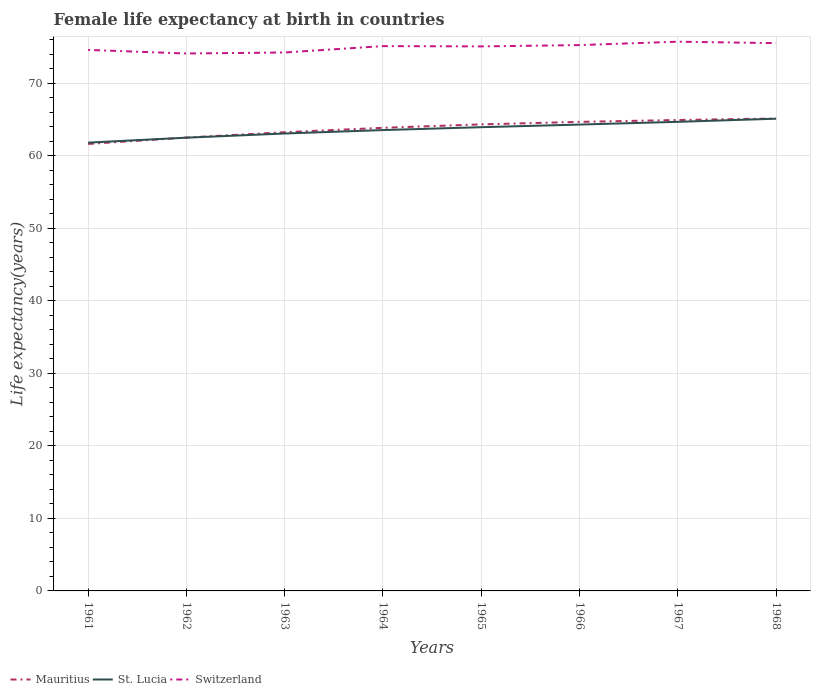Does the line corresponding to Switzerland intersect with the line corresponding to Mauritius?
Offer a terse response. No. Is the number of lines equal to the number of legend labels?
Your answer should be compact. Yes. Across all years, what is the maximum female life expectancy at birth in St. Lucia?
Your response must be concise. 61.8. In which year was the female life expectancy at birth in Switzerland maximum?
Provide a short and direct response. 1962. What is the total female life expectancy at birth in Mauritius in the graph?
Your answer should be very brief. -1.35. What is the difference between the highest and the second highest female life expectancy at birth in St. Lucia?
Offer a very short reply. 3.3. Is the female life expectancy at birth in Mauritius strictly greater than the female life expectancy at birth in St. Lucia over the years?
Your answer should be compact. No. Where does the legend appear in the graph?
Provide a short and direct response. Bottom left. What is the title of the graph?
Make the answer very short. Female life expectancy at birth in countries. Does "Congo (Republic)" appear as one of the legend labels in the graph?
Offer a very short reply. No. What is the label or title of the Y-axis?
Offer a very short reply. Life expectancy(years). What is the Life expectancy(years) in Mauritius in 1961?
Ensure brevity in your answer.  61.62. What is the Life expectancy(years) in St. Lucia in 1961?
Offer a terse response. 61.8. What is the Life expectancy(years) in Switzerland in 1961?
Ensure brevity in your answer.  74.59. What is the Life expectancy(years) of Mauritius in 1962?
Offer a terse response. 62.5. What is the Life expectancy(years) of St. Lucia in 1962?
Offer a very short reply. 62.49. What is the Life expectancy(years) in Switzerland in 1962?
Provide a succinct answer. 74.09. What is the Life expectancy(years) in Mauritius in 1963?
Keep it short and to the point. 63.24. What is the Life expectancy(years) of St. Lucia in 1963?
Make the answer very short. 63.06. What is the Life expectancy(years) in Switzerland in 1963?
Provide a short and direct response. 74.23. What is the Life expectancy(years) in Mauritius in 1964?
Keep it short and to the point. 63.85. What is the Life expectancy(years) in St. Lucia in 1964?
Your answer should be very brief. 63.53. What is the Life expectancy(years) in Switzerland in 1964?
Offer a terse response. 75.11. What is the Life expectancy(years) of Mauritius in 1965?
Give a very brief answer. 64.32. What is the Life expectancy(years) of St. Lucia in 1965?
Your answer should be very brief. 63.93. What is the Life expectancy(years) in Switzerland in 1965?
Your response must be concise. 75.07. What is the Life expectancy(years) in Mauritius in 1966?
Your answer should be very brief. 64.67. What is the Life expectancy(years) of St. Lucia in 1966?
Ensure brevity in your answer.  64.29. What is the Life expectancy(years) of Switzerland in 1966?
Offer a very short reply. 75.25. What is the Life expectancy(years) in Mauritius in 1967?
Ensure brevity in your answer.  64.92. What is the Life expectancy(years) of St. Lucia in 1967?
Provide a short and direct response. 64.67. What is the Life expectancy(years) in Switzerland in 1967?
Make the answer very short. 75.72. What is the Life expectancy(years) in Mauritius in 1968?
Make the answer very short. 65.13. What is the Life expectancy(years) of St. Lucia in 1968?
Your answer should be compact. 65.1. What is the Life expectancy(years) in Switzerland in 1968?
Provide a short and direct response. 75.52. Across all years, what is the maximum Life expectancy(years) of Mauritius?
Ensure brevity in your answer.  65.13. Across all years, what is the maximum Life expectancy(years) in St. Lucia?
Your answer should be compact. 65.1. Across all years, what is the maximum Life expectancy(years) in Switzerland?
Your response must be concise. 75.72. Across all years, what is the minimum Life expectancy(years) in Mauritius?
Your answer should be compact. 61.62. Across all years, what is the minimum Life expectancy(years) of St. Lucia?
Your answer should be compact. 61.8. Across all years, what is the minimum Life expectancy(years) of Switzerland?
Your response must be concise. 74.09. What is the total Life expectancy(years) in Mauritius in the graph?
Offer a very short reply. 510.25. What is the total Life expectancy(years) of St. Lucia in the graph?
Your answer should be compact. 508.89. What is the total Life expectancy(years) in Switzerland in the graph?
Offer a terse response. 599.58. What is the difference between the Life expectancy(years) of Mauritius in 1961 and that in 1962?
Provide a short and direct response. -0.88. What is the difference between the Life expectancy(years) in St. Lucia in 1961 and that in 1962?
Keep it short and to the point. -0.68. What is the difference between the Life expectancy(years) of Switzerland in 1961 and that in 1962?
Your response must be concise. 0.5. What is the difference between the Life expectancy(years) of Mauritius in 1961 and that in 1963?
Your response must be concise. -1.62. What is the difference between the Life expectancy(years) in St. Lucia in 1961 and that in 1963?
Offer a very short reply. -1.26. What is the difference between the Life expectancy(years) of Switzerland in 1961 and that in 1963?
Provide a short and direct response. 0.36. What is the difference between the Life expectancy(years) in Mauritius in 1961 and that in 1964?
Ensure brevity in your answer.  -2.23. What is the difference between the Life expectancy(years) of St. Lucia in 1961 and that in 1964?
Offer a very short reply. -1.73. What is the difference between the Life expectancy(years) of Switzerland in 1961 and that in 1964?
Ensure brevity in your answer.  -0.52. What is the difference between the Life expectancy(years) in Mauritius in 1961 and that in 1965?
Offer a very short reply. -2.7. What is the difference between the Life expectancy(years) in St. Lucia in 1961 and that in 1965?
Your answer should be very brief. -2.13. What is the difference between the Life expectancy(years) of Switzerland in 1961 and that in 1965?
Keep it short and to the point. -0.48. What is the difference between the Life expectancy(years) of Mauritius in 1961 and that in 1966?
Your answer should be compact. -3.04. What is the difference between the Life expectancy(years) in St. Lucia in 1961 and that in 1966?
Offer a very short reply. -2.49. What is the difference between the Life expectancy(years) in Switzerland in 1961 and that in 1966?
Keep it short and to the point. -0.66. What is the difference between the Life expectancy(years) in St. Lucia in 1961 and that in 1967?
Make the answer very short. -2.87. What is the difference between the Life expectancy(years) in Switzerland in 1961 and that in 1967?
Provide a succinct answer. -1.13. What is the difference between the Life expectancy(years) of Mauritius in 1961 and that in 1968?
Provide a succinct answer. -3.51. What is the difference between the Life expectancy(years) in St. Lucia in 1961 and that in 1968?
Keep it short and to the point. -3.3. What is the difference between the Life expectancy(years) of Switzerland in 1961 and that in 1968?
Offer a terse response. -0.93. What is the difference between the Life expectancy(years) of Mauritius in 1962 and that in 1963?
Your response must be concise. -0.74. What is the difference between the Life expectancy(years) of St. Lucia in 1962 and that in 1963?
Ensure brevity in your answer.  -0.57. What is the difference between the Life expectancy(years) of Switzerland in 1962 and that in 1963?
Offer a very short reply. -0.14. What is the difference between the Life expectancy(years) of Mauritius in 1962 and that in 1964?
Give a very brief answer. -1.35. What is the difference between the Life expectancy(years) in St. Lucia in 1962 and that in 1964?
Your answer should be compact. -1.05. What is the difference between the Life expectancy(years) of Switzerland in 1962 and that in 1964?
Provide a short and direct response. -1.02. What is the difference between the Life expectancy(years) in Mauritius in 1962 and that in 1965?
Give a very brief answer. -1.82. What is the difference between the Life expectancy(years) of St. Lucia in 1962 and that in 1965?
Make the answer very short. -1.45. What is the difference between the Life expectancy(years) in Switzerland in 1962 and that in 1965?
Make the answer very short. -0.98. What is the difference between the Life expectancy(years) of Mauritius in 1962 and that in 1966?
Your answer should be compact. -2.17. What is the difference between the Life expectancy(years) in St. Lucia in 1962 and that in 1966?
Give a very brief answer. -1.81. What is the difference between the Life expectancy(years) in Switzerland in 1962 and that in 1966?
Your answer should be very brief. -1.16. What is the difference between the Life expectancy(years) of Mauritius in 1962 and that in 1967?
Keep it short and to the point. -2.42. What is the difference between the Life expectancy(years) of St. Lucia in 1962 and that in 1967?
Make the answer very short. -2.19. What is the difference between the Life expectancy(years) of Switzerland in 1962 and that in 1967?
Your response must be concise. -1.63. What is the difference between the Life expectancy(years) in Mauritius in 1962 and that in 1968?
Provide a short and direct response. -2.63. What is the difference between the Life expectancy(years) in St. Lucia in 1962 and that in 1968?
Your response must be concise. -2.62. What is the difference between the Life expectancy(years) of Switzerland in 1962 and that in 1968?
Your answer should be very brief. -1.43. What is the difference between the Life expectancy(years) in Mauritius in 1963 and that in 1964?
Your response must be concise. -0.61. What is the difference between the Life expectancy(years) in St. Lucia in 1963 and that in 1964?
Give a very brief answer. -0.47. What is the difference between the Life expectancy(years) of Switzerland in 1963 and that in 1964?
Your answer should be very brief. -0.88. What is the difference between the Life expectancy(years) in Mauritius in 1963 and that in 1965?
Offer a very short reply. -1.08. What is the difference between the Life expectancy(years) in St. Lucia in 1963 and that in 1965?
Provide a succinct answer. -0.87. What is the difference between the Life expectancy(years) in Switzerland in 1963 and that in 1965?
Provide a short and direct response. -0.84. What is the difference between the Life expectancy(years) in Mauritius in 1963 and that in 1966?
Your answer should be very brief. -1.43. What is the difference between the Life expectancy(years) in St. Lucia in 1963 and that in 1966?
Your answer should be compact. -1.23. What is the difference between the Life expectancy(years) in Switzerland in 1963 and that in 1966?
Ensure brevity in your answer.  -1.02. What is the difference between the Life expectancy(years) of Mauritius in 1963 and that in 1967?
Offer a terse response. -1.68. What is the difference between the Life expectancy(years) in St. Lucia in 1963 and that in 1967?
Make the answer very short. -1.61. What is the difference between the Life expectancy(years) of Switzerland in 1963 and that in 1967?
Offer a terse response. -1.49. What is the difference between the Life expectancy(years) in Mauritius in 1963 and that in 1968?
Your answer should be compact. -1.89. What is the difference between the Life expectancy(years) of St. Lucia in 1963 and that in 1968?
Your response must be concise. -2.04. What is the difference between the Life expectancy(years) of Switzerland in 1963 and that in 1968?
Your response must be concise. -1.29. What is the difference between the Life expectancy(years) in Mauritius in 1964 and that in 1965?
Your answer should be very brief. -0.47. What is the difference between the Life expectancy(years) in St. Lucia in 1964 and that in 1965?
Give a very brief answer. -0.4. What is the difference between the Life expectancy(years) in Switzerland in 1964 and that in 1965?
Your response must be concise. 0.04. What is the difference between the Life expectancy(years) of Mauritius in 1964 and that in 1966?
Your answer should be compact. -0.82. What is the difference between the Life expectancy(years) in St. Lucia in 1964 and that in 1966?
Your answer should be compact. -0.76. What is the difference between the Life expectancy(years) in Switzerland in 1964 and that in 1966?
Offer a very short reply. -0.14. What is the difference between the Life expectancy(years) in Mauritius in 1964 and that in 1967?
Your answer should be compact. -1.07. What is the difference between the Life expectancy(years) of St. Lucia in 1964 and that in 1967?
Your answer should be very brief. -1.14. What is the difference between the Life expectancy(years) in Switzerland in 1964 and that in 1967?
Make the answer very short. -0.61. What is the difference between the Life expectancy(years) of Mauritius in 1964 and that in 1968?
Your response must be concise. -1.28. What is the difference between the Life expectancy(years) of St. Lucia in 1964 and that in 1968?
Make the answer very short. -1.57. What is the difference between the Life expectancy(years) in Switzerland in 1964 and that in 1968?
Give a very brief answer. -0.41. What is the difference between the Life expectancy(years) in Mauritius in 1965 and that in 1966?
Keep it short and to the point. -0.35. What is the difference between the Life expectancy(years) of St. Lucia in 1965 and that in 1966?
Provide a succinct answer. -0.36. What is the difference between the Life expectancy(years) in Switzerland in 1965 and that in 1966?
Provide a short and direct response. -0.18. What is the difference between the Life expectancy(years) of Mauritius in 1965 and that in 1967?
Your answer should be compact. -0.6. What is the difference between the Life expectancy(years) of St. Lucia in 1965 and that in 1967?
Offer a very short reply. -0.74. What is the difference between the Life expectancy(years) of Switzerland in 1965 and that in 1967?
Provide a succinct answer. -0.65. What is the difference between the Life expectancy(years) of Mauritius in 1965 and that in 1968?
Offer a very short reply. -0.81. What is the difference between the Life expectancy(years) in St. Lucia in 1965 and that in 1968?
Keep it short and to the point. -1.17. What is the difference between the Life expectancy(years) in Switzerland in 1965 and that in 1968?
Offer a very short reply. -0.45. What is the difference between the Life expectancy(years) in Mauritius in 1966 and that in 1967?
Your response must be concise. -0.26. What is the difference between the Life expectancy(years) of St. Lucia in 1966 and that in 1967?
Your answer should be very brief. -0.38. What is the difference between the Life expectancy(years) in Switzerland in 1966 and that in 1967?
Provide a short and direct response. -0.47. What is the difference between the Life expectancy(years) of Mauritius in 1966 and that in 1968?
Give a very brief answer. -0.46. What is the difference between the Life expectancy(years) of St. Lucia in 1966 and that in 1968?
Your response must be concise. -0.81. What is the difference between the Life expectancy(years) in Switzerland in 1966 and that in 1968?
Give a very brief answer. -0.27. What is the difference between the Life expectancy(years) in Mauritius in 1967 and that in 1968?
Make the answer very short. -0.21. What is the difference between the Life expectancy(years) in St. Lucia in 1967 and that in 1968?
Offer a very short reply. -0.43. What is the difference between the Life expectancy(years) in Switzerland in 1967 and that in 1968?
Make the answer very short. 0.2. What is the difference between the Life expectancy(years) of Mauritius in 1961 and the Life expectancy(years) of St. Lucia in 1962?
Your answer should be very brief. -0.86. What is the difference between the Life expectancy(years) of Mauritius in 1961 and the Life expectancy(years) of Switzerland in 1962?
Provide a short and direct response. -12.47. What is the difference between the Life expectancy(years) of St. Lucia in 1961 and the Life expectancy(years) of Switzerland in 1962?
Offer a very short reply. -12.29. What is the difference between the Life expectancy(years) of Mauritius in 1961 and the Life expectancy(years) of St. Lucia in 1963?
Make the answer very short. -1.44. What is the difference between the Life expectancy(years) of Mauritius in 1961 and the Life expectancy(years) of Switzerland in 1963?
Give a very brief answer. -12.61. What is the difference between the Life expectancy(years) in St. Lucia in 1961 and the Life expectancy(years) in Switzerland in 1963?
Ensure brevity in your answer.  -12.43. What is the difference between the Life expectancy(years) of Mauritius in 1961 and the Life expectancy(years) of St. Lucia in 1964?
Provide a short and direct response. -1.91. What is the difference between the Life expectancy(years) of Mauritius in 1961 and the Life expectancy(years) of Switzerland in 1964?
Offer a terse response. -13.49. What is the difference between the Life expectancy(years) in St. Lucia in 1961 and the Life expectancy(years) in Switzerland in 1964?
Provide a succinct answer. -13.31. What is the difference between the Life expectancy(years) of Mauritius in 1961 and the Life expectancy(years) of St. Lucia in 1965?
Your answer should be compact. -2.31. What is the difference between the Life expectancy(years) in Mauritius in 1961 and the Life expectancy(years) in Switzerland in 1965?
Ensure brevity in your answer.  -13.45. What is the difference between the Life expectancy(years) in St. Lucia in 1961 and the Life expectancy(years) in Switzerland in 1965?
Ensure brevity in your answer.  -13.27. What is the difference between the Life expectancy(years) of Mauritius in 1961 and the Life expectancy(years) of St. Lucia in 1966?
Provide a succinct answer. -2.67. What is the difference between the Life expectancy(years) of Mauritius in 1961 and the Life expectancy(years) of Switzerland in 1966?
Your response must be concise. -13.63. What is the difference between the Life expectancy(years) of St. Lucia in 1961 and the Life expectancy(years) of Switzerland in 1966?
Provide a short and direct response. -13.45. What is the difference between the Life expectancy(years) of Mauritius in 1961 and the Life expectancy(years) of St. Lucia in 1967?
Keep it short and to the point. -3.05. What is the difference between the Life expectancy(years) of Mauritius in 1961 and the Life expectancy(years) of Switzerland in 1967?
Ensure brevity in your answer.  -14.1. What is the difference between the Life expectancy(years) of St. Lucia in 1961 and the Life expectancy(years) of Switzerland in 1967?
Provide a succinct answer. -13.92. What is the difference between the Life expectancy(years) of Mauritius in 1961 and the Life expectancy(years) of St. Lucia in 1968?
Give a very brief answer. -3.48. What is the difference between the Life expectancy(years) of Mauritius in 1961 and the Life expectancy(years) of Switzerland in 1968?
Provide a succinct answer. -13.9. What is the difference between the Life expectancy(years) in St. Lucia in 1961 and the Life expectancy(years) in Switzerland in 1968?
Ensure brevity in your answer.  -13.72. What is the difference between the Life expectancy(years) of Mauritius in 1962 and the Life expectancy(years) of St. Lucia in 1963?
Offer a very short reply. -0.56. What is the difference between the Life expectancy(years) in Mauritius in 1962 and the Life expectancy(years) in Switzerland in 1963?
Provide a short and direct response. -11.73. What is the difference between the Life expectancy(years) in St. Lucia in 1962 and the Life expectancy(years) in Switzerland in 1963?
Ensure brevity in your answer.  -11.74. What is the difference between the Life expectancy(years) in Mauritius in 1962 and the Life expectancy(years) in St. Lucia in 1964?
Your answer should be very brief. -1.03. What is the difference between the Life expectancy(years) of Mauritius in 1962 and the Life expectancy(years) of Switzerland in 1964?
Offer a very short reply. -12.61. What is the difference between the Life expectancy(years) in St. Lucia in 1962 and the Life expectancy(years) in Switzerland in 1964?
Ensure brevity in your answer.  -12.62. What is the difference between the Life expectancy(years) of Mauritius in 1962 and the Life expectancy(years) of St. Lucia in 1965?
Keep it short and to the point. -1.43. What is the difference between the Life expectancy(years) of Mauritius in 1962 and the Life expectancy(years) of Switzerland in 1965?
Ensure brevity in your answer.  -12.57. What is the difference between the Life expectancy(years) of St. Lucia in 1962 and the Life expectancy(years) of Switzerland in 1965?
Ensure brevity in your answer.  -12.58. What is the difference between the Life expectancy(years) of Mauritius in 1962 and the Life expectancy(years) of St. Lucia in 1966?
Your answer should be compact. -1.79. What is the difference between the Life expectancy(years) of Mauritius in 1962 and the Life expectancy(years) of Switzerland in 1966?
Keep it short and to the point. -12.75. What is the difference between the Life expectancy(years) of St. Lucia in 1962 and the Life expectancy(years) of Switzerland in 1966?
Make the answer very short. -12.76. What is the difference between the Life expectancy(years) of Mauritius in 1962 and the Life expectancy(years) of St. Lucia in 1967?
Provide a succinct answer. -2.17. What is the difference between the Life expectancy(years) of Mauritius in 1962 and the Life expectancy(years) of Switzerland in 1967?
Your answer should be very brief. -13.22. What is the difference between the Life expectancy(years) of St. Lucia in 1962 and the Life expectancy(years) of Switzerland in 1967?
Your answer should be compact. -13.23. What is the difference between the Life expectancy(years) of Mauritius in 1962 and the Life expectancy(years) of St. Lucia in 1968?
Provide a short and direct response. -2.6. What is the difference between the Life expectancy(years) of Mauritius in 1962 and the Life expectancy(years) of Switzerland in 1968?
Provide a short and direct response. -13.02. What is the difference between the Life expectancy(years) of St. Lucia in 1962 and the Life expectancy(years) of Switzerland in 1968?
Ensure brevity in your answer.  -13.03. What is the difference between the Life expectancy(years) of Mauritius in 1963 and the Life expectancy(years) of St. Lucia in 1964?
Give a very brief answer. -0.29. What is the difference between the Life expectancy(years) in Mauritius in 1963 and the Life expectancy(years) in Switzerland in 1964?
Provide a succinct answer. -11.87. What is the difference between the Life expectancy(years) in St. Lucia in 1963 and the Life expectancy(years) in Switzerland in 1964?
Your answer should be very brief. -12.05. What is the difference between the Life expectancy(years) in Mauritius in 1963 and the Life expectancy(years) in St. Lucia in 1965?
Offer a very short reply. -0.69. What is the difference between the Life expectancy(years) in Mauritius in 1963 and the Life expectancy(years) in Switzerland in 1965?
Provide a short and direct response. -11.83. What is the difference between the Life expectancy(years) of St. Lucia in 1963 and the Life expectancy(years) of Switzerland in 1965?
Provide a short and direct response. -12.01. What is the difference between the Life expectancy(years) in Mauritius in 1963 and the Life expectancy(years) in St. Lucia in 1966?
Ensure brevity in your answer.  -1.05. What is the difference between the Life expectancy(years) in Mauritius in 1963 and the Life expectancy(years) in Switzerland in 1966?
Provide a succinct answer. -12.01. What is the difference between the Life expectancy(years) of St. Lucia in 1963 and the Life expectancy(years) of Switzerland in 1966?
Offer a very short reply. -12.19. What is the difference between the Life expectancy(years) in Mauritius in 1963 and the Life expectancy(years) in St. Lucia in 1967?
Provide a short and direct response. -1.43. What is the difference between the Life expectancy(years) of Mauritius in 1963 and the Life expectancy(years) of Switzerland in 1967?
Offer a terse response. -12.48. What is the difference between the Life expectancy(years) of St. Lucia in 1963 and the Life expectancy(years) of Switzerland in 1967?
Ensure brevity in your answer.  -12.66. What is the difference between the Life expectancy(years) in Mauritius in 1963 and the Life expectancy(years) in St. Lucia in 1968?
Provide a succinct answer. -1.86. What is the difference between the Life expectancy(years) in Mauritius in 1963 and the Life expectancy(years) in Switzerland in 1968?
Provide a succinct answer. -12.28. What is the difference between the Life expectancy(years) of St. Lucia in 1963 and the Life expectancy(years) of Switzerland in 1968?
Provide a succinct answer. -12.46. What is the difference between the Life expectancy(years) in Mauritius in 1964 and the Life expectancy(years) in St. Lucia in 1965?
Provide a short and direct response. -0.08. What is the difference between the Life expectancy(years) in Mauritius in 1964 and the Life expectancy(years) in Switzerland in 1965?
Give a very brief answer. -11.22. What is the difference between the Life expectancy(years) of St. Lucia in 1964 and the Life expectancy(years) of Switzerland in 1965?
Give a very brief answer. -11.54. What is the difference between the Life expectancy(years) in Mauritius in 1964 and the Life expectancy(years) in St. Lucia in 1966?
Offer a terse response. -0.45. What is the difference between the Life expectancy(years) of Mauritius in 1964 and the Life expectancy(years) of Switzerland in 1966?
Keep it short and to the point. -11.4. What is the difference between the Life expectancy(years) of St. Lucia in 1964 and the Life expectancy(years) of Switzerland in 1966?
Your answer should be compact. -11.71. What is the difference between the Life expectancy(years) of Mauritius in 1964 and the Life expectancy(years) of St. Lucia in 1967?
Offer a terse response. -0.82. What is the difference between the Life expectancy(years) in Mauritius in 1964 and the Life expectancy(years) in Switzerland in 1967?
Offer a very short reply. -11.87. What is the difference between the Life expectancy(years) of St. Lucia in 1964 and the Life expectancy(years) of Switzerland in 1967?
Keep it short and to the point. -12.19. What is the difference between the Life expectancy(years) in Mauritius in 1964 and the Life expectancy(years) in St. Lucia in 1968?
Your answer should be compact. -1.25. What is the difference between the Life expectancy(years) of Mauritius in 1964 and the Life expectancy(years) of Switzerland in 1968?
Offer a very short reply. -11.67. What is the difference between the Life expectancy(years) of St. Lucia in 1964 and the Life expectancy(years) of Switzerland in 1968?
Provide a succinct answer. -11.98. What is the difference between the Life expectancy(years) of Mauritius in 1965 and the Life expectancy(years) of St. Lucia in 1966?
Give a very brief answer. 0.03. What is the difference between the Life expectancy(years) in Mauritius in 1965 and the Life expectancy(years) in Switzerland in 1966?
Provide a short and direct response. -10.93. What is the difference between the Life expectancy(years) in St. Lucia in 1965 and the Life expectancy(years) in Switzerland in 1966?
Provide a short and direct response. -11.32. What is the difference between the Life expectancy(years) in Mauritius in 1965 and the Life expectancy(years) in St. Lucia in 1967?
Provide a succinct answer. -0.35. What is the difference between the Life expectancy(years) of Mauritius in 1965 and the Life expectancy(years) of Switzerland in 1967?
Make the answer very short. -11.4. What is the difference between the Life expectancy(years) of St. Lucia in 1965 and the Life expectancy(years) of Switzerland in 1967?
Your answer should be very brief. -11.79. What is the difference between the Life expectancy(years) in Mauritius in 1965 and the Life expectancy(years) in St. Lucia in 1968?
Offer a very short reply. -0.78. What is the difference between the Life expectancy(years) of St. Lucia in 1965 and the Life expectancy(years) of Switzerland in 1968?
Your response must be concise. -11.59. What is the difference between the Life expectancy(years) in Mauritius in 1966 and the Life expectancy(years) in St. Lucia in 1967?
Your response must be concise. -0.01. What is the difference between the Life expectancy(years) in Mauritius in 1966 and the Life expectancy(years) in Switzerland in 1967?
Offer a very short reply. -11.05. What is the difference between the Life expectancy(years) of St. Lucia in 1966 and the Life expectancy(years) of Switzerland in 1967?
Offer a terse response. -11.43. What is the difference between the Life expectancy(years) in Mauritius in 1966 and the Life expectancy(years) in St. Lucia in 1968?
Provide a short and direct response. -0.44. What is the difference between the Life expectancy(years) of Mauritius in 1966 and the Life expectancy(years) of Switzerland in 1968?
Your answer should be very brief. -10.85. What is the difference between the Life expectancy(years) in St. Lucia in 1966 and the Life expectancy(years) in Switzerland in 1968?
Your response must be concise. -11.23. What is the difference between the Life expectancy(years) of Mauritius in 1967 and the Life expectancy(years) of St. Lucia in 1968?
Provide a succinct answer. -0.18. What is the difference between the Life expectancy(years) of Mauritius in 1967 and the Life expectancy(years) of Switzerland in 1968?
Keep it short and to the point. -10.6. What is the difference between the Life expectancy(years) of St. Lucia in 1967 and the Life expectancy(years) of Switzerland in 1968?
Give a very brief answer. -10.85. What is the average Life expectancy(years) in Mauritius per year?
Your response must be concise. 63.78. What is the average Life expectancy(years) in St. Lucia per year?
Provide a short and direct response. 63.61. What is the average Life expectancy(years) in Switzerland per year?
Your answer should be very brief. 74.95. In the year 1961, what is the difference between the Life expectancy(years) in Mauritius and Life expectancy(years) in St. Lucia?
Keep it short and to the point. -0.18. In the year 1961, what is the difference between the Life expectancy(years) of Mauritius and Life expectancy(years) of Switzerland?
Your response must be concise. -12.97. In the year 1961, what is the difference between the Life expectancy(years) in St. Lucia and Life expectancy(years) in Switzerland?
Keep it short and to the point. -12.79. In the year 1962, what is the difference between the Life expectancy(years) in Mauritius and Life expectancy(years) in St. Lucia?
Provide a succinct answer. 0.01. In the year 1962, what is the difference between the Life expectancy(years) of Mauritius and Life expectancy(years) of Switzerland?
Ensure brevity in your answer.  -11.59. In the year 1962, what is the difference between the Life expectancy(years) of St. Lucia and Life expectancy(years) of Switzerland?
Provide a succinct answer. -11.6. In the year 1963, what is the difference between the Life expectancy(years) of Mauritius and Life expectancy(years) of St. Lucia?
Provide a short and direct response. 0.18. In the year 1963, what is the difference between the Life expectancy(years) in Mauritius and Life expectancy(years) in Switzerland?
Make the answer very short. -10.99. In the year 1963, what is the difference between the Life expectancy(years) of St. Lucia and Life expectancy(years) of Switzerland?
Your response must be concise. -11.17. In the year 1964, what is the difference between the Life expectancy(years) in Mauritius and Life expectancy(years) in St. Lucia?
Your answer should be compact. 0.31. In the year 1964, what is the difference between the Life expectancy(years) of Mauritius and Life expectancy(years) of Switzerland?
Make the answer very short. -11.26. In the year 1964, what is the difference between the Life expectancy(years) in St. Lucia and Life expectancy(years) in Switzerland?
Ensure brevity in your answer.  -11.57. In the year 1965, what is the difference between the Life expectancy(years) in Mauritius and Life expectancy(years) in St. Lucia?
Ensure brevity in your answer.  0.39. In the year 1965, what is the difference between the Life expectancy(years) of Mauritius and Life expectancy(years) of Switzerland?
Offer a very short reply. -10.75. In the year 1965, what is the difference between the Life expectancy(years) in St. Lucia and Life expectancy(years) in Switzerland?
Make the answer very short. -11.14. In the year 1966, what is the difference between the Life expectancy(years) of Mauritius and Life expectancy(years) of St. Lucia?
Your response must be concise. 0.37. In the year 1966, what is the difference between the Life expectancy(years) of Mauritius and Life expectancy(years) of Switzerland?
Provide a succinct answer. -10.58. In the year 1966, what is the difference between the Life expectancy(years) of St. Lucia and Life expectancy(years) of Switzerland?
Ensure brevity in your answer.  -10.96. In the year 1967, what is the difference between the Life expectancy(years) in Mauritius and Life expectancy(years) in St. Lucia?
Offer a very short reply. 0.25. In the year 1967, what is the difference between the Life expectancy(years) of Mauritius and Life expectancy(years) of Switzerland?
Offer a very short reply. -10.8. In the year 1967, what is the difference between the Life expectancy(years) of St. Lucia and Life expectancy(years) of Switzerland?
Offer a terse response. -11.05. In the year 1968, what is the difference between the Life expectancy(years) of Mauritius and Life expectancy(years) of St. Lucia?
Make the answer very short. 0.03. In the year 1968, what is the difference between the Life expectancy(years) of Mauritius and Life expectancy(years) of Switzerland?
Offer a very short reply. -10.39. In the year 1968, what is the difference between the Life expectancy(years) in St. Lucia and Life expectancy(years) in Switzerland?
Give a very brief answer. -10.42. What is the ratio of the Life expectancy(years) of Mauritius in 1961 to that in 1962?
Keep it short and to the point. 0.99. What is the ratio of the Life expectancy(years) in St. Lucia in 1961 to that in 1962?
Offer a very short reply. 0.99. What is the ratio of the Life expectancy(years) in Mauritius in 1961 to that in 1963?
Keep it short and to the point. 0.97. What is the ratio of the Life expectancy(years) of St. Lucia in 1961 to that in 1963?
Give a very brief answer. 0.98. What is the ratio of the Life expectancy(years) in Switzerland in 1961 to that in 1963?
Provide a short and direct response. 1. What is the ratio of the Life expectancy(years) of Mauritius in 1961 to that in 1964?
Provide a short and direct response. 0.97. What is the ratio of the Life expectancy(years) of St. Lucia in 1961 to that in 1964?
Provide a succinct answer. 0.97. What is the ratio of the Life expectancy(years) of Mauritius in 1961 to that in 1965?
Your response must be concise. 0.96. What is the ratio of the Life expectancy(years) in St. Lucia in 1961 to that in 1965?
Your answer should be compact. 0.97. What is the ratio of the Life expectancy(years) in Switzerland in 1961 to that in 1965?
Your response must be concise. 0.99. What is the ratio of the Life expectancy(years) of Mauritius in 1961 to that in 1966?
Offer a very short reply. 0.95. What is the ratio of the Life expectancy(years) of St. Lucia in 1961 to that in 1966?
Keep it short and to the point. 0.96. What is the ratio of the Life expectancy(years) in Mauritius in 1961 to that in 1967?
Give a very brief answer. 0.95. What is the ratio of the Life expectancy(years) of St. Lucia in 1961 to that in 1967?
Ensure brevity in your answer.  0.96. What is the ratio of the Life expectancy(years) in Switzerland in 1961 to that in 1967?
Your answer should be compact. 0.99. What is the ratio of the Life expectancy(years) in Mauritius in 1961 to that in 1968?
Offer a terse response. 0.95. What is the ratio of the Life expectancy(years) of St. Lucia in 1961 to that in 1968?
Offer a terse response. 0.95. What is the ratio of the Life expectancy(years) of Mauritius in 1962 to that in 1963?
Keep it short and to the point. 0.99. What is the ratio of the Life expectancy(years) of St. Lucia in 1962 to that in 1963?
Ensure brevity in your answer.  0.99. What is the ratio of the Life expectancy(years) in Mauritius in 1962 to that in 1964?
Provide a succinct answer. 0.98. What is the ratio of the Life expectancy(years) in St. Lucia in 1962 to that in 1964?
Make the answer very short. 0.98. What is the ratio of the Life expectancy(years) in Switzerland in 1962 to that in 1964?
Provide a short and direct response. 0.99. What is the ratio of the Life expectancy(years) of Mauritius in 1962 to that in 1965?
Give a very brief answer. 0.97. What is the ratio of the Life expectancy(years) of St. Lucia in 1962 to that in 1965?
Offer a very short reply. 0.98. What is the ratio of the Life expectancy(years) in Switzerland in 1962 to that in 1965?
Provide a short and direct response. 0.99. What is the ratio of the Life expectancy(years) in Mauritius in 1962 to that in 1966?
Provide a short and direct response. 0.97. What is the ratio of the Life expectancy(years) in St. Lucia in 1962 to that in 1966?
Your answer should be compact. 0.97. What is the ratio of the Life expectancy(years) in Switzerland in 1962 to that in 1966?
Offer a terse response. 0.98. What is the ratio of the Life expectancy(years) in Mauritius in 1962 to that in 1967?
Offer a very short reply. 0.96. What is the ratio of the Life expectancy(years) of St. Lucia in 1962 to that in 1967?
Your response must be concise. 0.97. What is the ratio of the Life expectancy(years) in Switzerland in 1962 to that in 1967?
Give a very brief answer. 0.98. What is the ratio of the Life expectancy(years) in Mauritius in 1962 to that in 1968?
Provide a succinct answer. 0.96. What is the ratio of the Life expectancy(years) of St. Lucia in 1962 to that in 1968?
Ensure brevity in your answer.  0.96. What is the ratio of the Life expectancy(years) in Switzerland in 1962 to that in 1968?
Your answer should be compact. 0.98. What is the ratio of the Life expectancy(years) in Mauritius in 1963 to that in 1964?
Your response must be concise. 0.99. What is the ratio of the Life expectancy(years) of Switzerland in 1963 to that in 1964?
Keep it short and to the point. 0.99. What is the ratio of the Life expectancy(years) of Mauritius in 1963 to that in 1965?
Offer a very short reply. 0.98. What is the ratio of the Life expectancy(years) of St. Lucia in 1963 to that in 1965?
Your answer should be compact. 0.99. What is the ratio of the Life expectancy(years) of Mauritius in 1963 to that in 1966?
Keep it short and to the point. 0.98. What is the ratio of the Life expectancy(years) of St. Lucia in 1963 to that in 1966?
Make the answer very short. 0.98. What is the ratio of the Life expectancy(years) of Switzerland in 1963 to that in 1966?
Your answer should be very brief. 0.99. What is the ratio of the Life expectancy(years) of Mauritius in 1963 to that in 1967?
Make the answer very short. 0.97. What is the ratio of the Life expectancy(years) of St. Lucia in 1963 to that in 1967?
Provide a succinct answer. 0.98. What is the ratio of the Life expectancy(years) of Switzerland in 1963 to that in 1967?
Offer a very short reply. 0.98. What is the ratio of the Life expectancy(years) of Mauritius in 1963 to that in 1968?
Provide a succinct answer. 0.97. What is the ratio of the Life expectancy(years) in St. Lucia in 1963 to that in 1968?
Ensure brevity in your answer.  0.97. What is the ratio of the Life expectancy(years) in Switzerland in 1963 to that in 1968?
Keep it short and to the point. 0.98. What is the ratio of the Life expectancy(years) of St. Lucia in 1964 to that in 1965?
Give a very brief answer. 0.99. What is the ratio of the Life expectancy(years) of Mauritius in 1964 to that in 1966?
Give a very brief answer. 0.99. What is the ratio of the Life expectancy(years) in St. Lucia in 1964 to that in 1966?
Keep it short and to the point. 0.99. What is the ratio of the Life expectancy(years) in Mauritius in 1964 to that in 1967?
Ensure brevity in your answer.  0.98. What is the ratio of the Life expectancy(years) of St. Lucia in 1964 to that in 1967?
Your response must be concise. 0.98. What is the ratio of the Life expectancy(years) of Mauritius in 1964 to that in 1968?
Keep it short and to the point. 0.98. What is the ratio of the Life expectancy(years) of St. Lucia in 1964 to that in 1968?
Keep it short and to the point. 0.98. What is the ratio of the Life expectancy(years) in Switzerland in 1964 to that in 1968?
Offer a terse response. 0.99. What is the ratio of the Life expectancy(years) of Mauritius in 1965 to that in 1966?
Make the answer very short. 0.99. What is the ratio of the Life expectancy(years) of St. Lucia in 1965 to that in 1966?
Keep it short and to the point. 0.99. What is the ratio of the Life expectancy(years) in Switzerland in 1965 to that in 1966?
Your answer should be compact. 1. What is the ratio of the Life expectancy(years) of Mauritius in 1965 to that in 1968?
Provide a short and direct response. 0.99. What is the ratio of the Life expectancy(years) of Mauritius in 1966 to that in 1967?
Your answer should be very brief. 1. What is the ratio of the Life expectancy(years) in St. Lucia in 1966 to that in 1968?
Provide a succinct answer. 0.99. What is the ratio of the Life expectancy(years) of Mauritius in 1967 to that in 1968?
Your answer should be compact. 1. What is the ratio of the Life expectancy(years) of Switzerland in 1967 to that in 1968?
Provide a short and direct response. 1. What is the difference between the highest and the second highest Life expectancy(years) in Mauritius?
Provide a short and direct response. 0.21. What is the difference between the highest and the second highest Life expectancy(years) in St. Lucia?
Provide a short and direct response. 0.43. What is the difference between the highest and the second highest Life expectancy(years) in Switzerland?
Give a very brief answer. 0.2. What is the difference between the highest and the lowest Life expectancy(years) in Mauritius?
Offer a very short reply. 3.51. What is the difference between the highest and the lowest Life expectancy(years) of St. Lucia?
Your answer should be very brief. 3.3. What is the difference between the highest and the lowest Life expectancy(years) of Switzerland?
Your answer should be very brief. 1.63. 